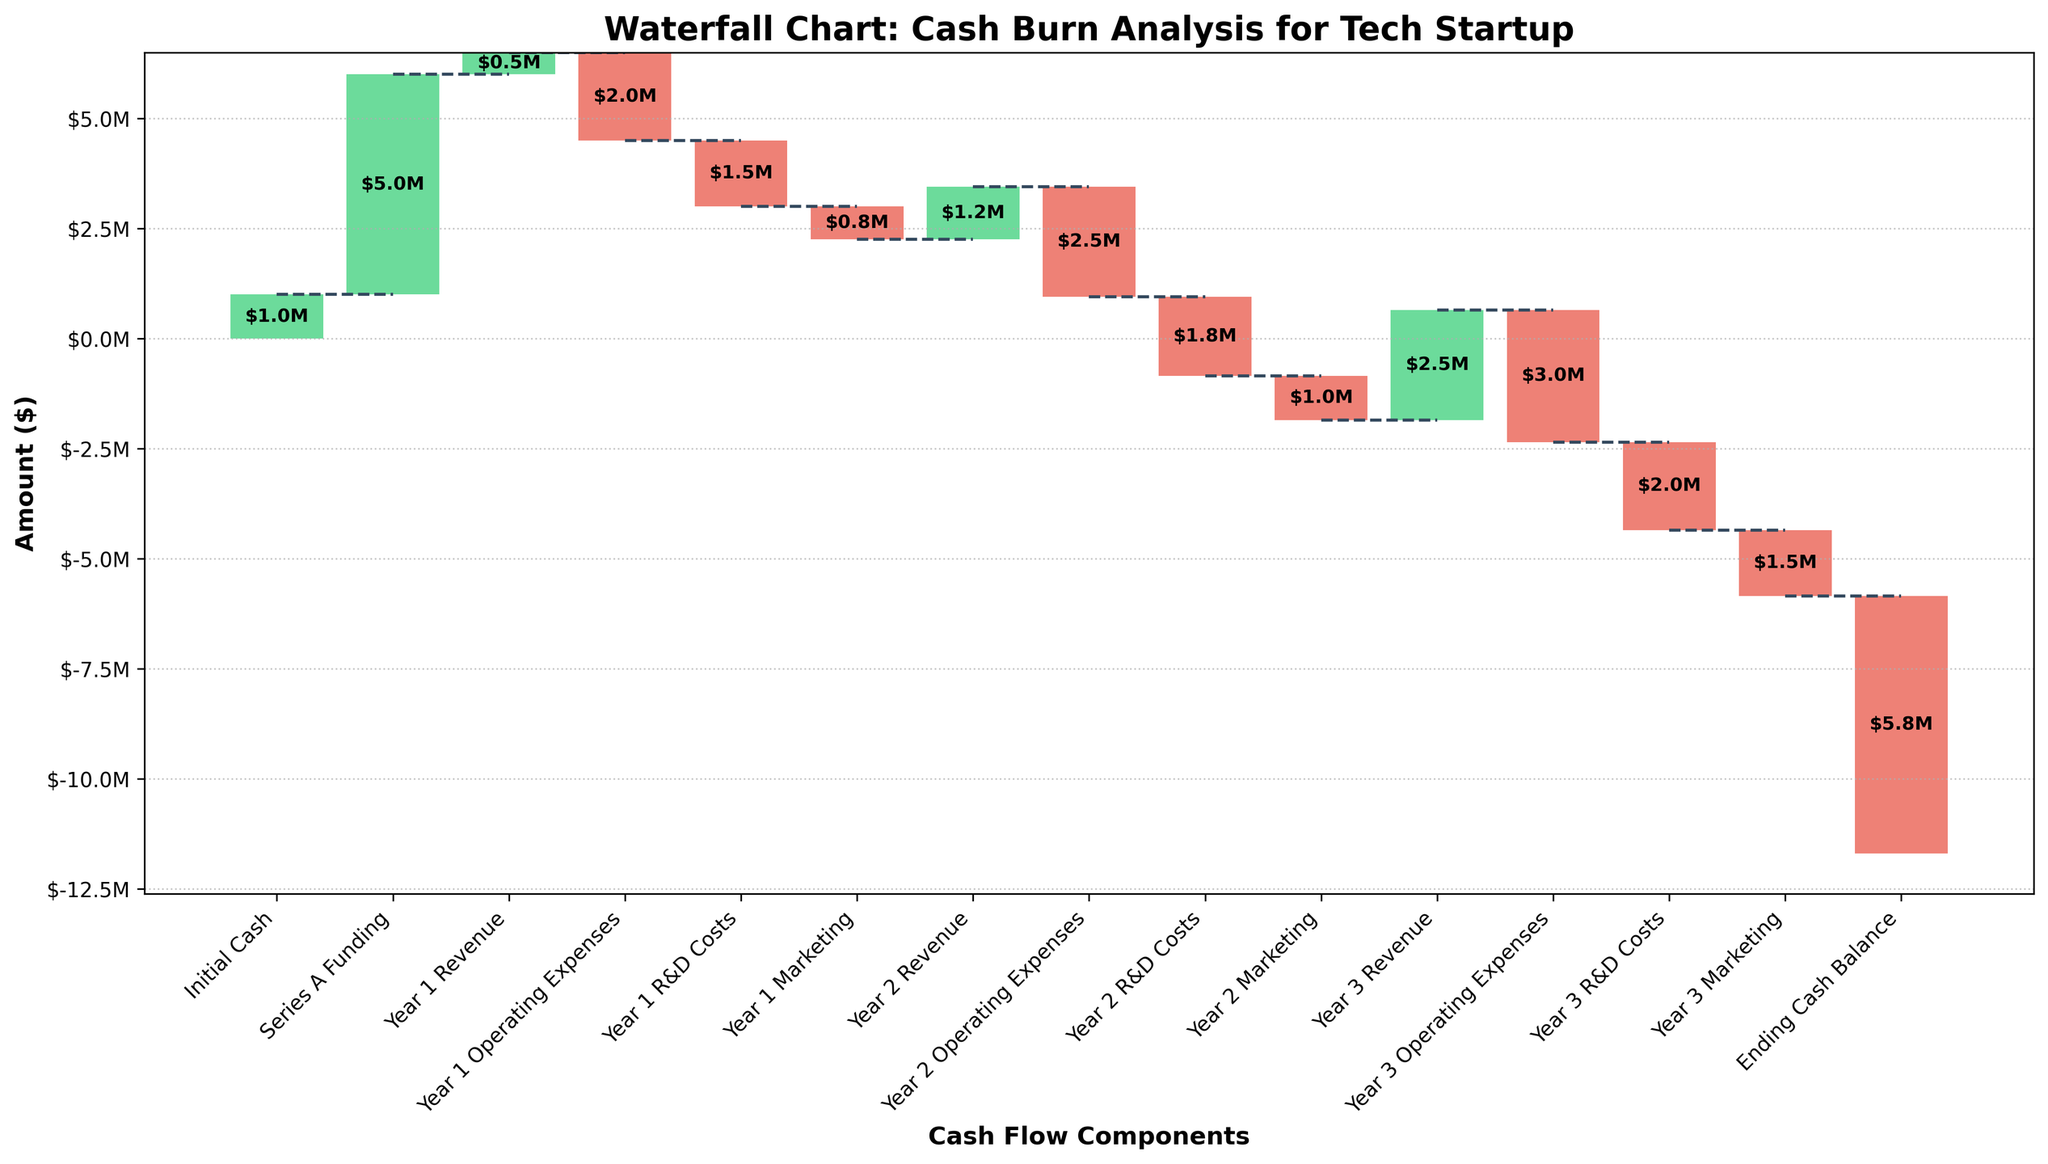What is the title of the figure? The title is located at the top of the figure and is visually distinguishable by its larger font size and bold formatting.
Answer: Waterfall Chart: Cash Burn Analysis for Tech Startup How many categories are displayed in the chart? The x-axis shows the categories, and each category has a corresponding bar. By counting the categories labeled on the x-axis, we find the total number.
Answer: 15 What is the initial cash amount for the startup? The initial cash amount is represented by the first bar labeled "Initial Cash." The height of this bar gives the value.
Answer: $1,000,000 How much Series A Funding did the startup receive? The bar labeled "Series A Funding" represents this amount; its height indicates the value.
Answer: $5,000,000 What is the cumulative cash amount after Year 1 Revenue? The cumulative amount is shown above each bar, so you find the cumulative value above the "Year 1 Revenue" bar.
Answer: $6,500,000 What is the net change in cash from Year 1 Operating Expenses, R&D Costs, and Marketing combined? Add the amounts of Year 1 Operating Expenses, R&D Costs, and Marketing (all negative), then sum these up for the net change. Calculation: -$2,000,000 - $1,500,000 - $750,000 = -$4,250,000
Answer: -$4,250,000 What is the cumulative cash amount at the end of Year 2? The cumulative amount at the end of Year 2 is shown above the last bar of Year 2, which is "Year 2 Marketing."
Answer: $700,000 How do Year 2 R&D Costs compare to Year 1 R&D Costs? Compare the values of the bars labeled "Year 2 R&D Costs" and "Year 1 R&D Costs" to see which is larger or smaller.
Answer: Year 2 R&D Costs are $300,000 larger What is the total revenue over the three years? Add the revenues from "Year 1 Revenue," "Year 2 Revenue," and "Year 3 Revenue." Calculation: $500,000 + $1,200,000 + $2,500,000 = $4,200,000
Answer: $4,200,000 What is the cash balance at the end of the third year? The final cumulative amount is shown at the "Ending Cash Balance" bar, which represents the amount after all revenues and expenses.
Answer: -$5,850,000 